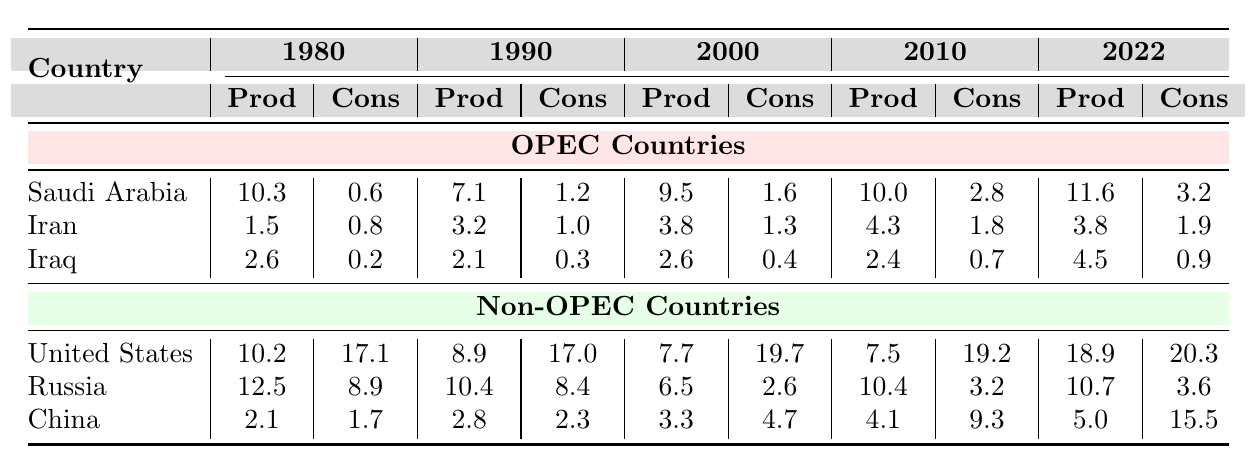What was the oil production of Saudi Arabia in 2010? The table shows that Saudi Arabia's oil production in 2010 is listed as 10.0 million barrels per day.
Answer: 10.0 million barrels per day What was the oil consumption of Iran in 1980? According to the table, Iran's oil consumption in 1980 is reported as 0.8 million barrels per day.
Answer: 0.8 million barrels per day Which country had the highest oil consumption in 2022? In 2022, the United States had the highest oil consumption at 20.3 million barrels per day, based on the consumption figures in the table.
Answer: United States What is the difference in oil production between Iraq in 2022 and Iraq in 1980? The table states that Iraq's production in 2022 is 4.5 and in 1980 is 2.6. The difference is calculated as 4.5 - 2.6 = 1.9 million barrels per day.
Answer: 1.9 million barrels per day What was the average oil production for non-OPEC countries in 2022? The production values for non-OPEC countries in 2022 are: United States (18.9), Russia (10.7), and China (5.0). Summing these gives 18.9 + 10.7 + 5.0 = 34.6. Then, dividing by 3 gives an average of 34.6 / 3 ≈ 11.53 million barrels per day.
Answer: Approximately 11.53 million barrels per day Did Iran's oil production increase from 1980 to 2010? Comparing the values shows that Iran's production in 1980 was 1.5 and in 2010 it was 4.3, indicating an increase of 4.3 - 1.5 = 2.8 million barrels per day. Thus, the answer is yes.
Answer: Yes Which country saw the largest increase in oil consumption between 1980 and 2022? Calculating the increase for each country: United States (20.3 - 17.1 = 3.2), Russia (3.6 - 8.9 = -5.3), China (15.5 - 1.7 = 13.8), Saudi Arabia (3.2 - 0.6 = 2.6), Iran (1.9 - 0.8 = 1.1), and Iraq (0.9 - 0.2 = 0.7). The largest increase is from China, which saw an increase of 13.8 million barrels per day.
Answer: China How much more oil did the United States consume than Iraq in 2010? The table shows that the United States consumed 19.2 million barrels per day and Iraq consumed 0.7 million barrels per day in 2010. The difference is 19.2 - 0.7 = 18.5 million barrels per day.
Answer: 18.5 million barrels per day 